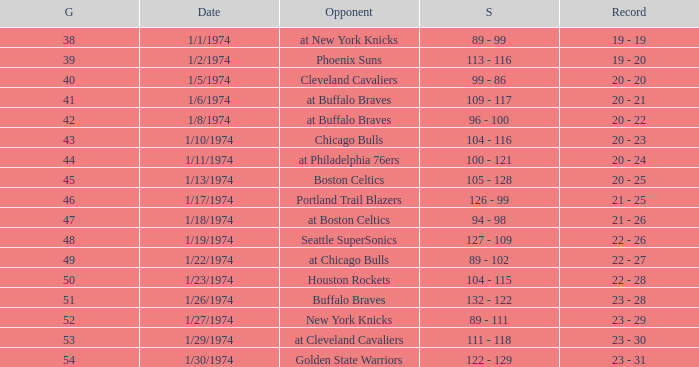What was the score on 1/10/1974? 104 - 116. 